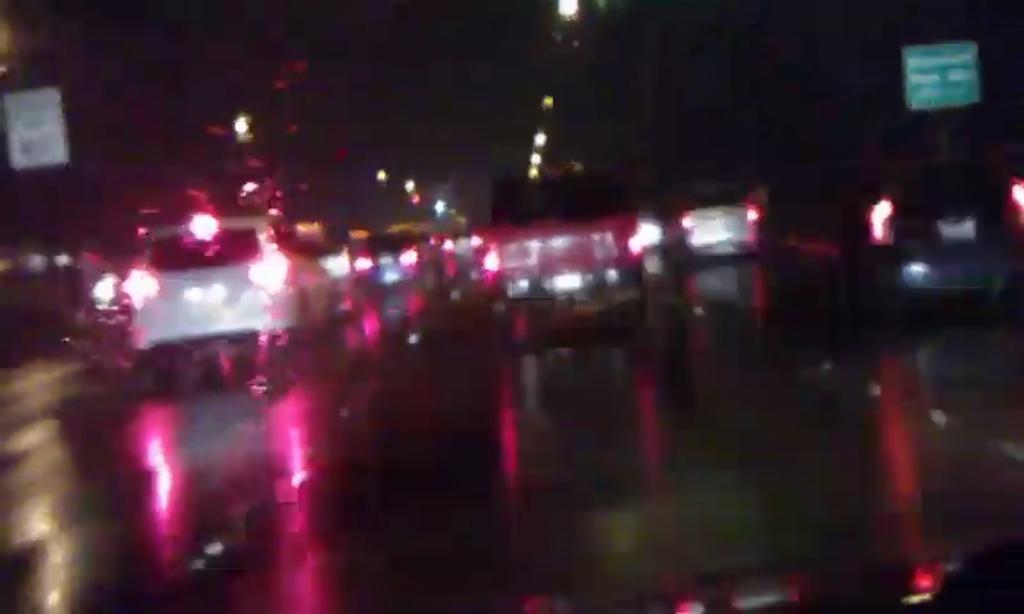Can you describe this image briefly? In this image there is a road and we can see vehicles on the road. There are boards and we can see lights. 